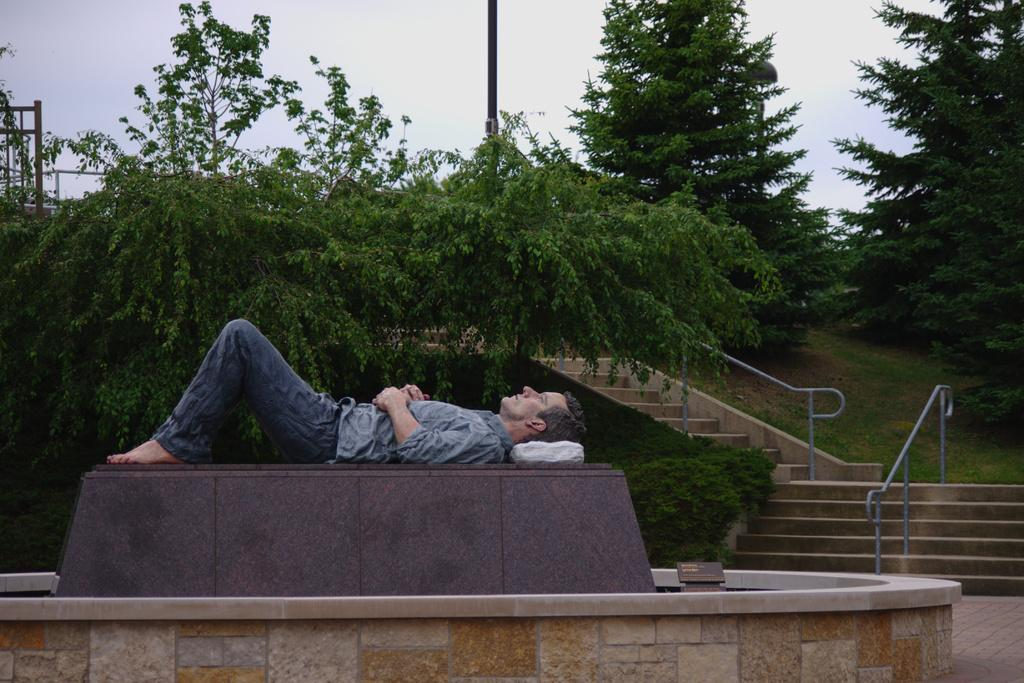What is the man doing in the image? The man is lying on the fountain. What can be seen on the right side of the image? There are stairs with railing on the right side. What type of vegetation is visible in the background? There are trees in the backdrop. How would you describe the sky in the image? The sky is clear in the image. What is the angle of the addition to the building in the image? There is no addition to the building in the image, so it is not possible to determine the angle. 